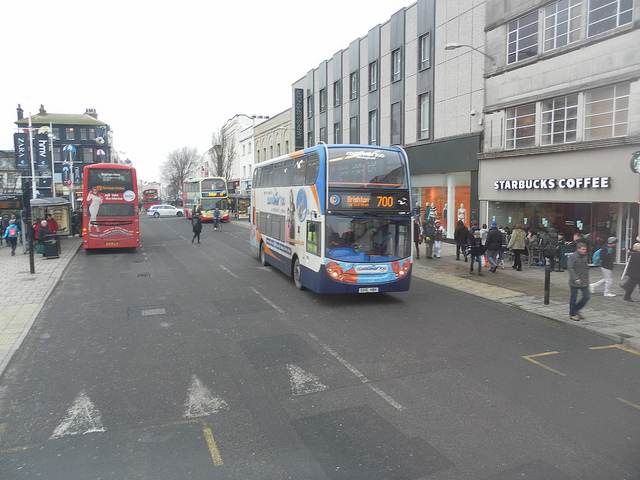Create two realistic scenarios people might experience in this scene. One long and one short. Long Scenario: John, a middle-aged office worker, hustled out of the Starbucks, gripping his hot coffee as he rushed towards the oncoming bus 700. His mind buzzed with the day's tasks and upcoming meetings. As he boarded the bus and found a seat by the window, he took a moment to watch the street's hustle and bustle, allowing himself a rare moment of calm before diving into the chaos of his workday. He glanced at his watch and sighed, realizing he'd have to skip lunch again to meet the looming deadlines. The familiar hum of the bus and the morning caffeine surge helped him gear up mentally for another demanding day at the office. Short Scenario: Sarah, a student, stood anxiously beside the road, waving urgently at the passing bus. She was running late for her final exam and couldn’t afford to miss this bus. The look of relief on her face as the bus stopped for her was unmistakable. 